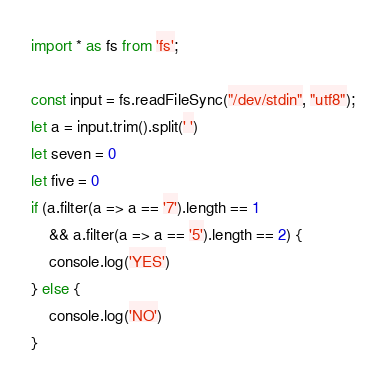Convert code to text. <code><loc_0><loc_0><loc_500><loc_500><_TypeScript_>import * as fs from 'fs';

const input = fs.readFileSync("/dev/stdin", "utf8");
let a = input.trim().split(' ')
let seven = 0
let five = 0
if (a.filter(a => a == '7').length == 1
	&& a.filter(a => a == '5').length == 2) {
	console.log('YES')
} else {
	console.log('NO')
}
</code> 